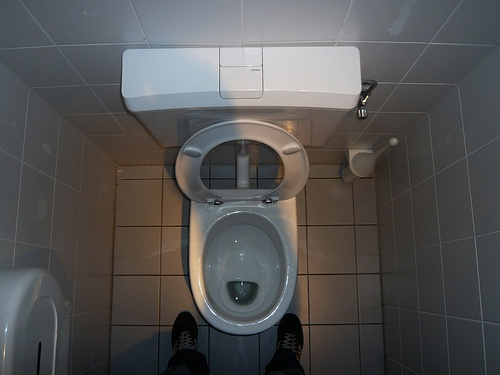Describe the objects in this image and their specific colors. I can see toilet in purple, gray, lightgray, darkgray, and black tones and people in purple, black, and gray tones in this image. 